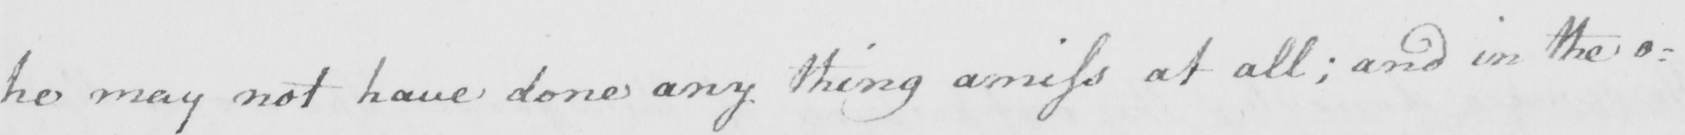Can you tell me what this handwritten text says? he may not have done any thing amiss at all  ; and in the o= 